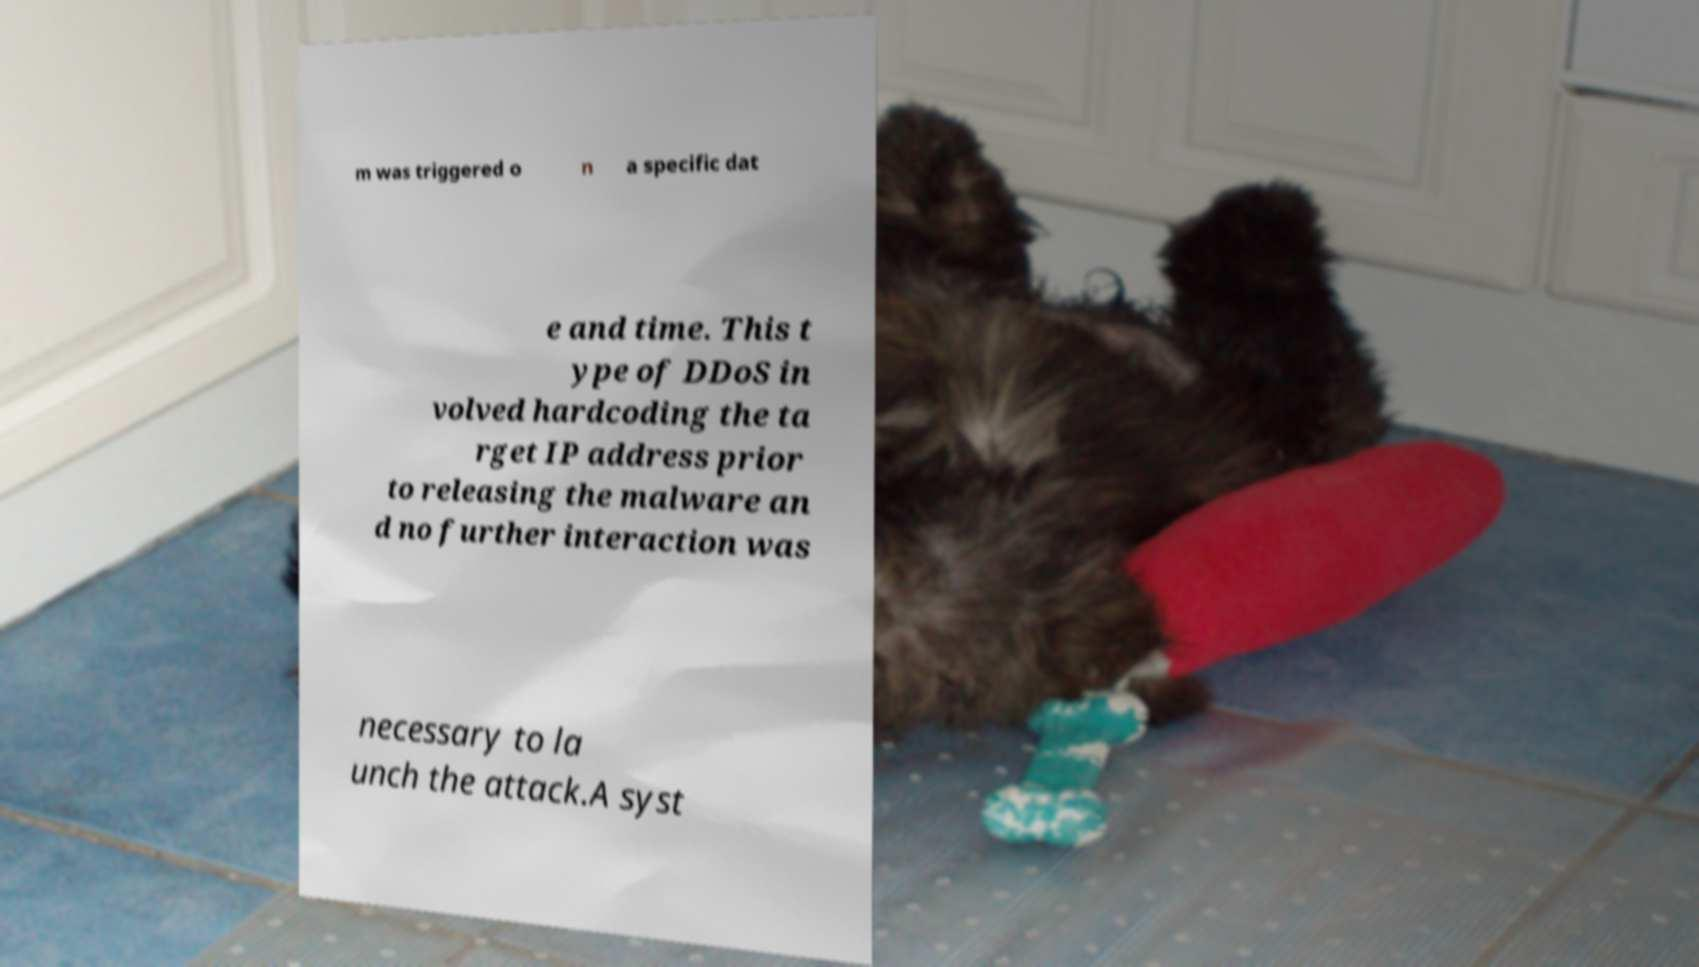I need the written content from this picture converted into text. Can you do that? m was triggered o n a specific dat e and time. This t ype of DDoS in volved hardcoding the ta rget IP address prior to releasing the malware an d no further interaction was necessary to la unch the attack.A syst 